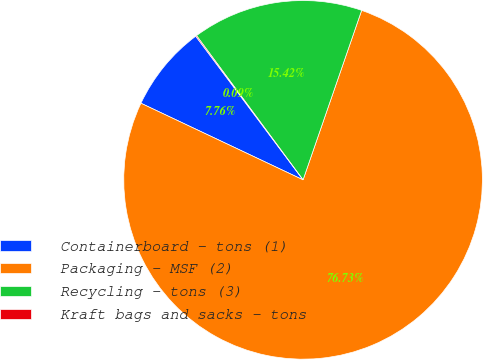Convert chart to OTSL. <chart><loc_0><loc_0><loc_500><loc_500><pie_chart><fcel>Containerboard - tons (1)<fcel>Packaging - MSF (2)<fcel>Recycling - tons (3)<fcel>Kraft bags and sacks - tons<nl><fcel>7.76%<fcel>76.73%<fcel>15.42%<fcel>0.09%<nl></chart> 